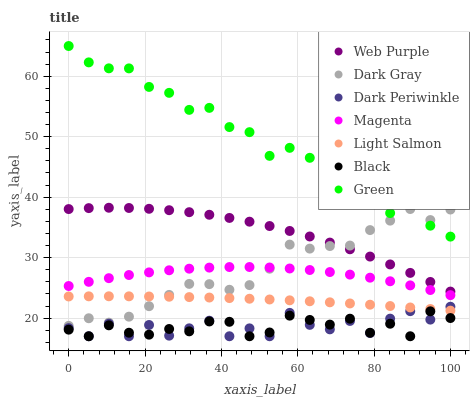Does Black have the minimum area under the curve?
Answer yes or no. Yes. Does Green have the maximum area under the curve?
Answer yes or no. Yes. Does Dark Gray have the minimum area under the curve?
Answer yes or no. No. Does Dark Gray have the maximum area under the curve?
Answer yes or no. No. Is Light Salmon the smoothest?
Answer yes or no. Yes. Is Dark Periwinkle the roughest?
Answer yes or no. Yes. Is Dark Gray the smoothest?
Answer yes or no. No. Is Dark Gray the roughest?
Answer yes or no. No. Does Black have the lowest value?
Answer yes or no. Yes. Does Dark Gray have the lowest value?
Answer yes or no. No. Does Green have the highest value?
Answer yes or no. Yes. Does Dark Gray have the highest value?
Answer yes or no. No. Is Black less than Dark Gray?
Answer yes or no. Yes. Is Green greater than Web Purple?
Answer yes or no. Yes. Does Magenta intersect Dark Gray?
Answer yes or no. Yes. Is Magenta less than Dark Gray?
Answer yes or no. No. Is Magenta greater than Dark Gray?
Answer yes or no. No. Does Black intersect Dark Gray?
Answer yes or no. No. 